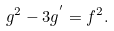<formula> <loc_0><loc_0><loc_500><loc_500>g ^ { 2 } - 3 g ^ { ^ { \prime } } = f ^ { 2 } .</formula> 